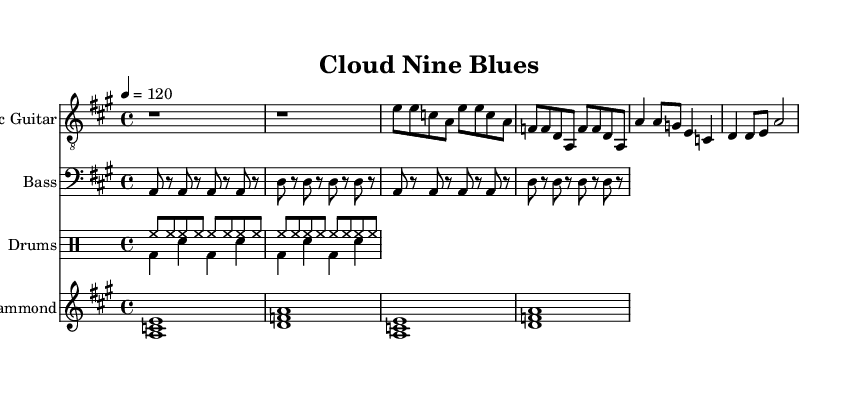What is the key signature of this music? The key signature is indicated by the presence of sharps or flats at the beginning of the staff. In this case, there are no sharps or flats shown, which suggests it is in the key of A major.
Answer: A major What is the time signature of this piece? The time signature is indicated at the start of the staff and shows how many beats there are in each measure. Here, it's 4/4, indicating four beats per measure.
Answer: 4/4 What is the tempo marking for this track? The tempo marking is generally placed near the top of the score. In this case, it states "4 = 120," meaning the quarter note gets 120 beats per minute.
Answer: 120 How many measures are there in the verse? To determine the number of measures, we can count the sections marked for the verse. The verse section includes four measures, as shown by the structure under the electric guitar part.
Answer: 4 What instrument plays the main melody in this piece? The main melody is often played by the instrument that has the lead part. In this case, the electric guitar is shown to play the primary melodic lines throughout the music.
Answer: Electric guitar What lyrical theme is expressed in the chorus? The chorus reveals the lyrical content associated with the music's theme. Here, the lyrics focus on connectivity and an uplifting concept, stating, "We're riding on Cloud Nine." This suggests a positive and celebratory theme connected to data and connectivity.
Answer: Connectivity How does the rhythm section contribute to the upbeat feel of the music? By examining the drum patterns, bass lines, and their coordinated sounds, we can conclude that a consistent beat combined with syncopated drum hits serves to create an energetic and lively rhythm that embodies the upbeat nature of electric blues. The drums maintain a steady backbeat while the bass outlines a rhythmic foundation supporting the upbeat feel.
Answer: Energetic and lively rhythm 